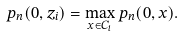Convert formula to latex. <formula><loc_0><loc_0><loc_500><loc_500>p _ { n } ( 0 , z _ { i } ) = \max _ { x \in C _ { i } } p _ { n } ( 0 , x ) .</formula> 